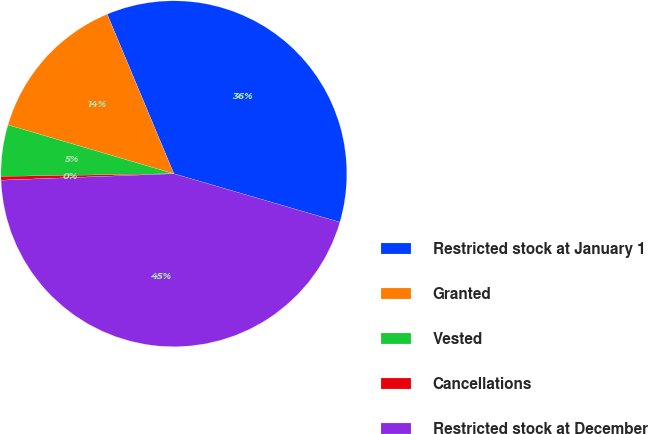Convert chart to OTSL. <chart><loc_0><loc_0><loc_500><loc_500><pie_chart><fcel>Restricted stock at January 1<fcel>Granted<fcel>Vested<fcel>Cancellations<fcel>Restricted stock at December<nl><fcel>35.82%<fcel>14.14%<fcel>4.8%<fcel>0.35%<fcel>44.88%<nl></chart> 